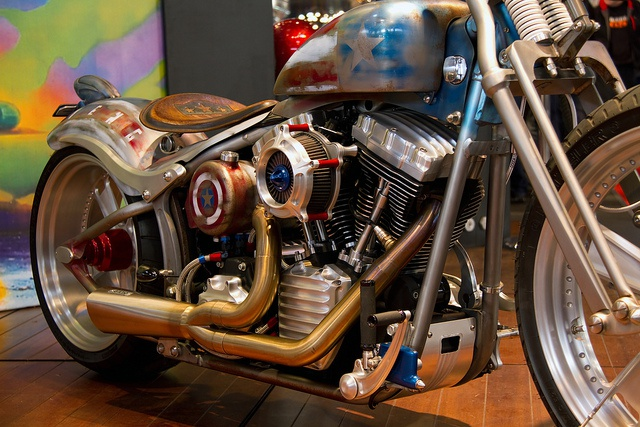Describe the objects in this image and their specific colors. I can see a motorcycle in gray, black, and maroon tones in this image. 